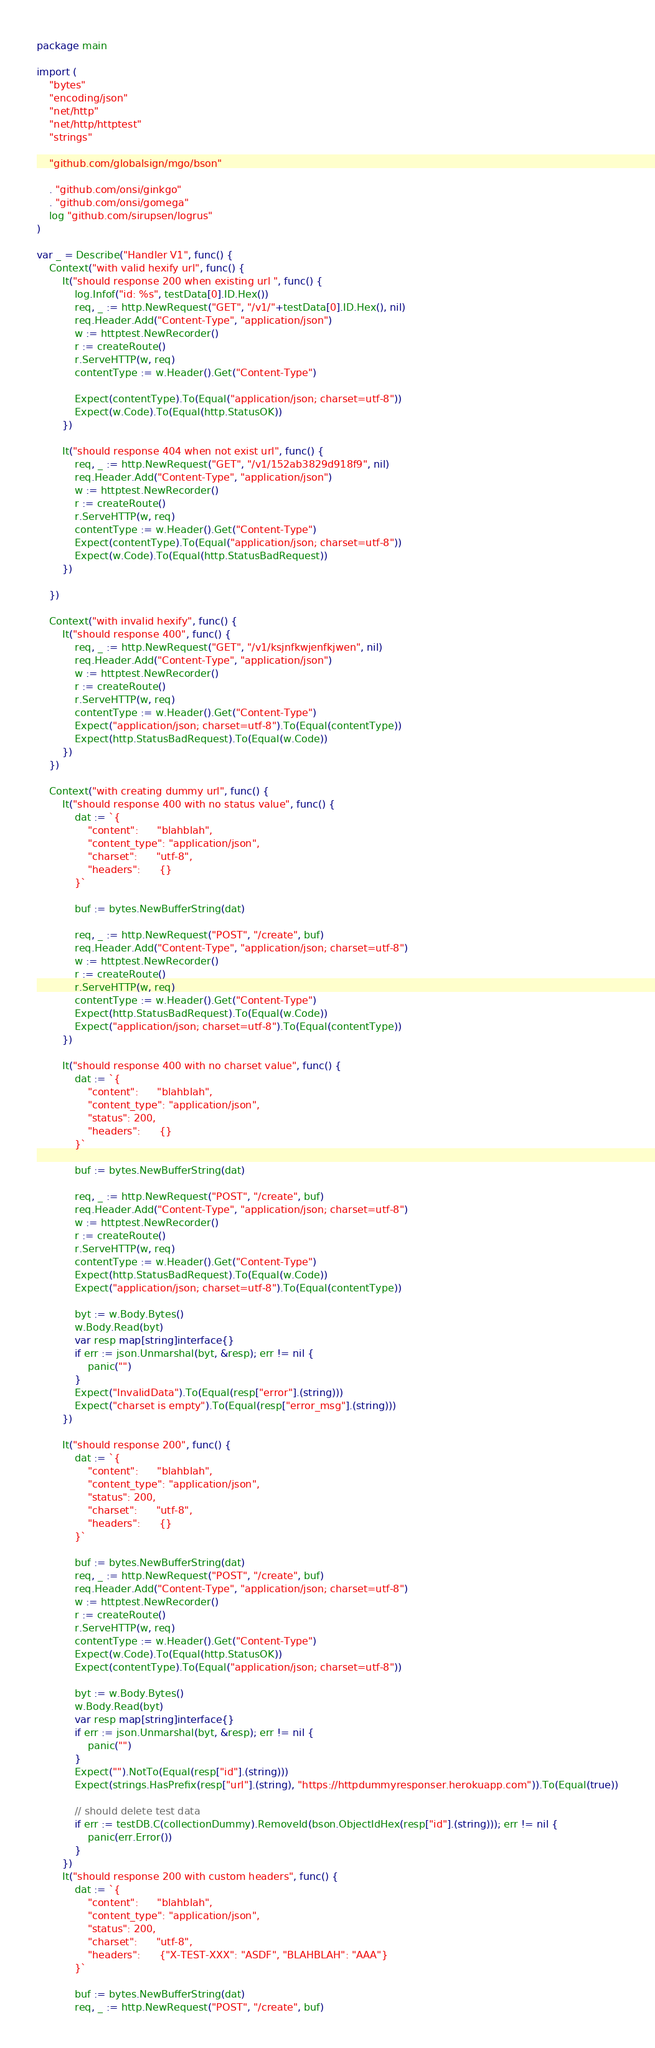<code> <loc_0><loc_0><loc_500><loc_500><_Go_>package main

import (
	"bytes"
	"encoding/json"
	"net/http"
	"net/http/httptest"
	"strings"

	"github.com/globalsign/mgo/bson"

	. "github.com/onsi/ginkgo"
	. "github.com/onsi/gomega"
	log "github.com/sirupsen/logrus"
)

var _ = Describe("Handler V1", func() {
	Context("with valid hexify url", func() {
		It("should response 200 when existing url ", func() {
			log.Infof("id: %s", testData[0].ID.Hex())
			req, _ := http.NewRequest("GET", "/v1/"+testData[0].ID.Hex(), nil)
			req.Header.Add("Content-Type", "application/json")
			w := httptest.NewRecorder()
			r := createRoute()
			r.ServeHTTP(w, req)
			contentType := w.Header().Get("Content-Type")

			Expect(contentType).To(Equal("application/json; charset=utf-8"))
			Expect(w.Code).To(Equal(http.StatusOK))
		})

		It("should response 404 when not exist url", func() {
			req, _ := http.NewRequest("GET", "/v1/152ab3829d918f9", nil)
			req.Header.Add("Content-Type", "application/json")
			w := httptest.NewRecorder()
			r := createRoute()
			r.ServeHTTP(w, req)
			contentType := w.Header().Get("Content-Type")
			Expect(contentType).To(Equal("application/json; charset=utf-8"))
			Expect(w.Code).To(Equal(http.StatusBadRequest))
		})

	})

	Context("with invalid hexify", func() {
		It("should response 400", func() {
			req, _ := http.NewRequest("GET", "/v1/ksjnfkwjenfkjwen", nil)
			req.Header.Add("Content-Type", "application/json")
			w := httptest.NewRecorder()
			r := createRoute()
			r.ServeHTTP(w, req)
			contentType := w.Header().Get("Content-Type")
			Expect("application/json; charset=utf-8").To(Equal(contentType))
			Expect(http.StatusBadRequest).To(Equal(w.Code))
		})
	})

	Context("with creating dummy url", func() {
		It("should response 400 with no status value", func() {
			dat := `{
				"content":      "blahblah",
				"content_type": "application/json",
				"charset":      "utf-8",
				"headers":      {}
			}`

			buf := bytes.NewBufferString(dat)

			req, _ := http.NewRequest("POST", "/create", buf)
			req.Header.Add("Content-Type", "application/json; charset=utf-8")
			w := httptest.NewRecorder()
			r := createRoute()
			r.ServeHTTP(w, req)
			contentType := w.Header().Get("Content-Type")
			Expect(http.StatusBadRequest).To(Equal(w.Code))
			Expect("application/json; charset=utf-8").To(Equal(contentType))
		})

		It("should response 400 with no charset value", func() {
			dat := `{
				"content":      "blahblah",
				"content_type": "application/json",
				"status": 200,
				"headers":      {}
			}`

			buf := bytes.NewBufferString(dat)

			req, _ := http.NewRequest("POST", "/create", buf)
			req.Header.Add("Content-Type", "application/json; charset=utf-8")
			w := httptest.NewRecorder()
			r := createRoute()
			r.ServeHTTP(w, req)
			contentType := w.Header().Get("Content-Type")
			Expect(http.StatusBadRequest).To(Equal(w.Code))
			Expect("application/json; charset=utf-8").To(Equal(contentType))

			byt := w.Body.Bytes()
			w.Body.Read(byt)
			var resp map[string]interface{}
			if err := json.Unmarshal(byt, &resp); err != nil {
				panic("")
			}
			Expect("InvalidData").To(Equal(resp["error"].(string)))
			Expect("charset is empty").To(Equal(resp["error_msg"].(string)))
		})

		It("should response 200", func() {
			dat := `{
				"content":      "blahblah",
				"content_type": "application/json",
				"status": 200,
				"charset":      "utf-8",
				"headers":      {}
			}`

			buf := bytes.NewBufferString(dat)
			req, _ := http.NewRequest("POST", "/create", buf)
			req.Header.Add("Content-Type", "application/json; charset=utf-8")
			w := httptest.NewRecorder()
			r := createRoute()
			r.ServeHTTP(w, req)
			contentType := w.Header().Get("Content-Type")
			Expect(w.Code).To(Equal(http.StatusOK))
			Expect(contentType).To(Equal("application/json; charset=utf-8"))

			byt := w.Body.Bytes()
			w.Body.Read(byt)
			var resp map[string]interface{}
			if err := json.Unmarshal(byt, &resp); err != nil {
				panic("")
			}
			Expect("").NotTo(Equal(resp["id"].(string)))
			Expect(strings.HasPrefix(resp["url"].(string), "https://httpdummyresponser.herokuapp.com")).To(Equal(true))

			// should delete test data
			if err := testDB.C(collectionDummy).RemoveId(bson.ObjectIdHex(resp["id"].(string))); err != nil {
				panic(err.Error())
			}
		})
		It("should response 200 with custom headers", func() {
			dat := `{
				"content":      "blahblah",
				"content_type": "application/json",
				"status": 200,
				"charset":      "utf-8",
				"headers":      {"X-TEST-XXX": "ASDF", "BLAHBLAH": "AAA"}
			}`

			buf := bytes.NewBufferString(dat)
			req, _ := http.NewRequest("POST", "/create", buf)</code> 